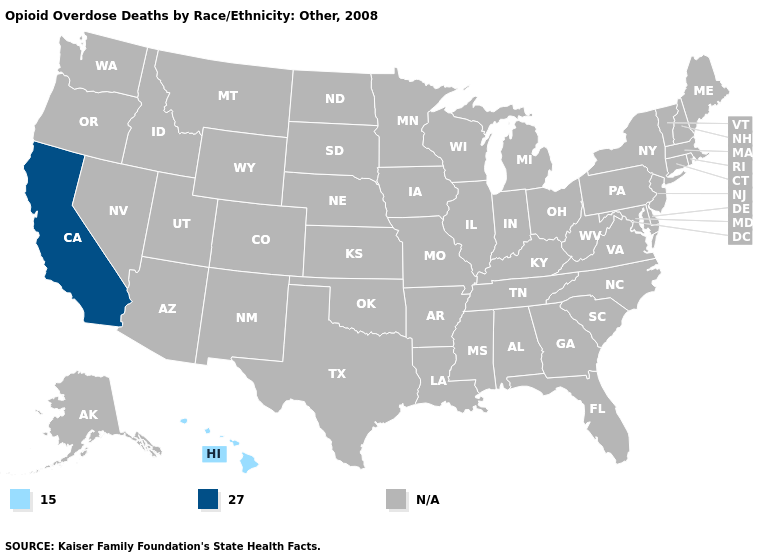Which states have the highest value in the USA?
Be succinct. California. What is the value of Alabama?
Answer briefly. N/A. How many symbols are there in the legend?
Short answer required. 3. Which states have the lowest value in the USA?
Short answer required. Hawaii. What is the highest value in the USA?
Keep it brief. 27.0. Does Hawaii have the highest value in the USA?
Give a very brief answer. No. Does the map have missing data?
Short answer required. Yes. What is the value of Missouri?
Answer briefly. N/A. Name the states that have a value in the range N/A?
Keep it brief. Alabama, Alaska, Arizona, Arkansas, Colorado, Connecticut, Delaware, Florida, Georgia, Idaho, Illinois, Indiana, Iowa, Kansas, Kentucky, Louisiana, Maine, Maryland, Massachusetts, Michigan, Minnesota, Mississippi, Missouri, Montana, Nebraska, Nevada, New Hampshire, New Jersey, New Mexico, New York, North Carolina, North Dakota, Ohio, Oklahoma, Oregon, Pennsylvania, Rhode Island, South Carolina, South Dakota, Tennessee, Texas, Utah, Vermont, Virginia, Washington, West Virginia, Wisconsin, Wyoming. What is the highest value in the USA?
Answer briefly. 27.0. What is the value of Michigan?
Answer briefly. N/A. 